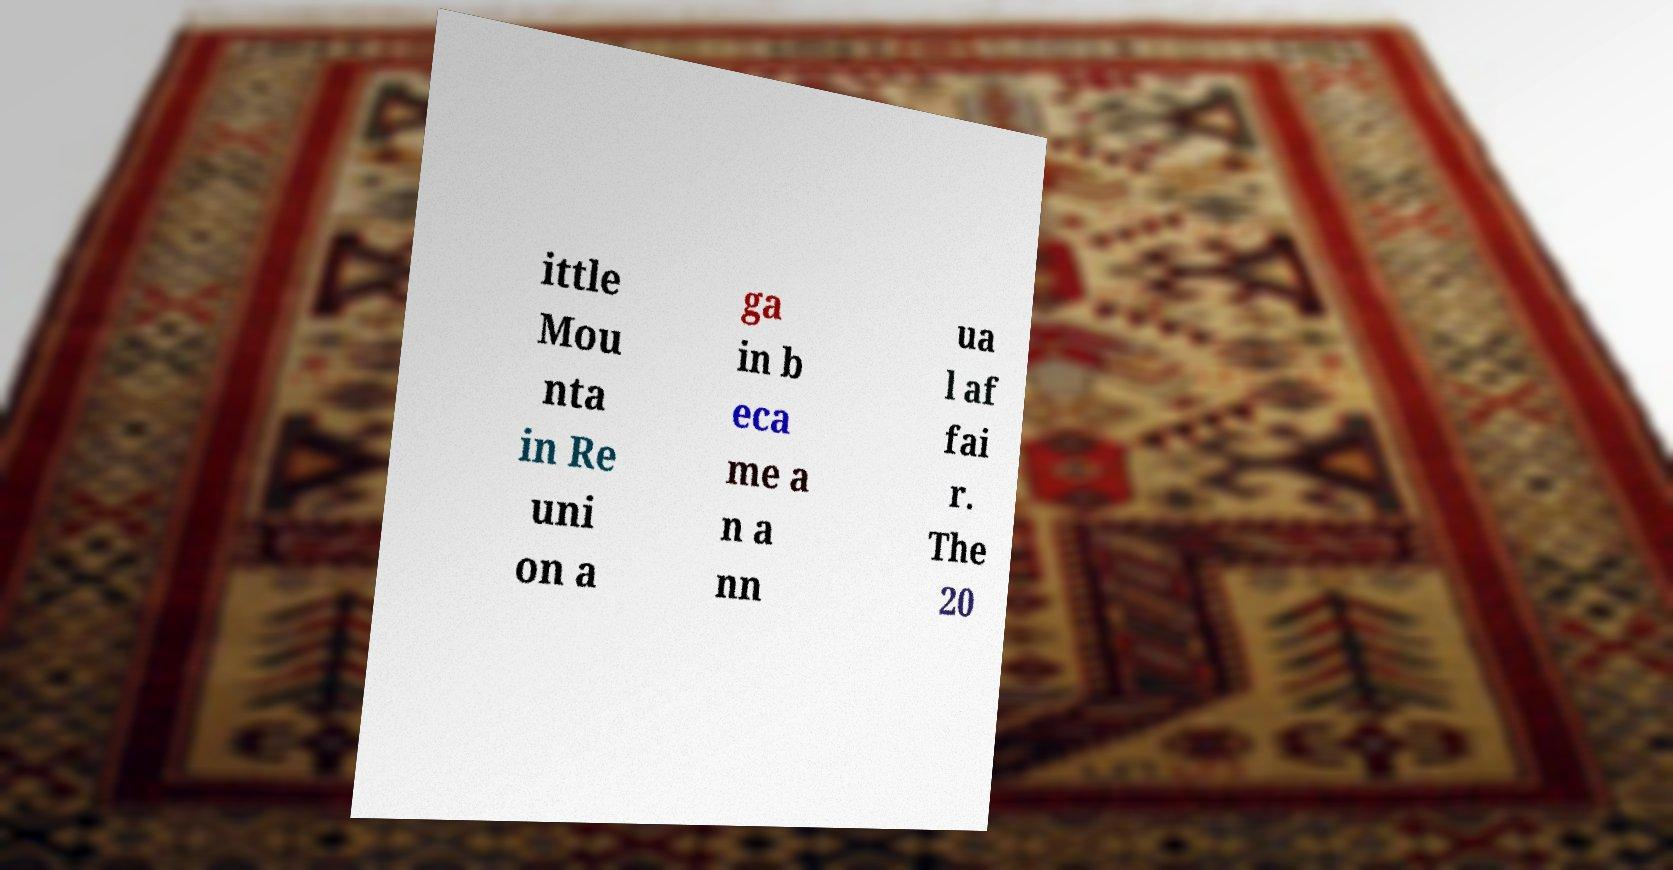There's text embedded in this image that I need extracted. Can you transcribe it verbatim? ittle Mou nta in Re uni on a ga in b eca me a n a nn ua l af fai r. The 20 